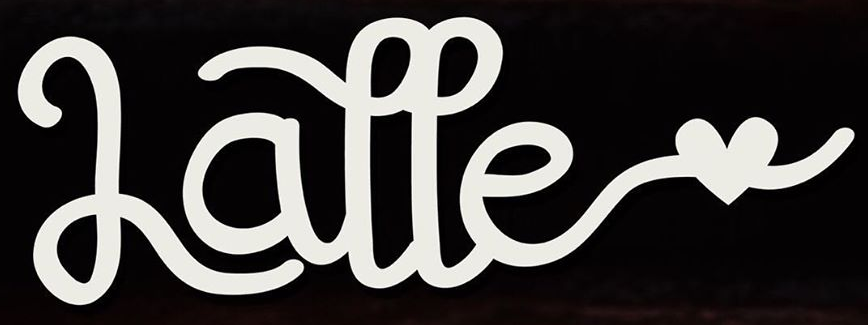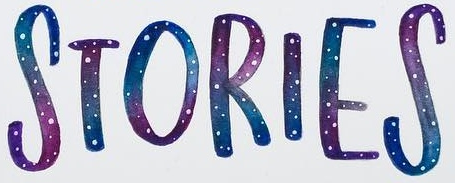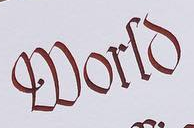What words are shown in these images in order, separated by a semicolon? Latte; STORIES; World 